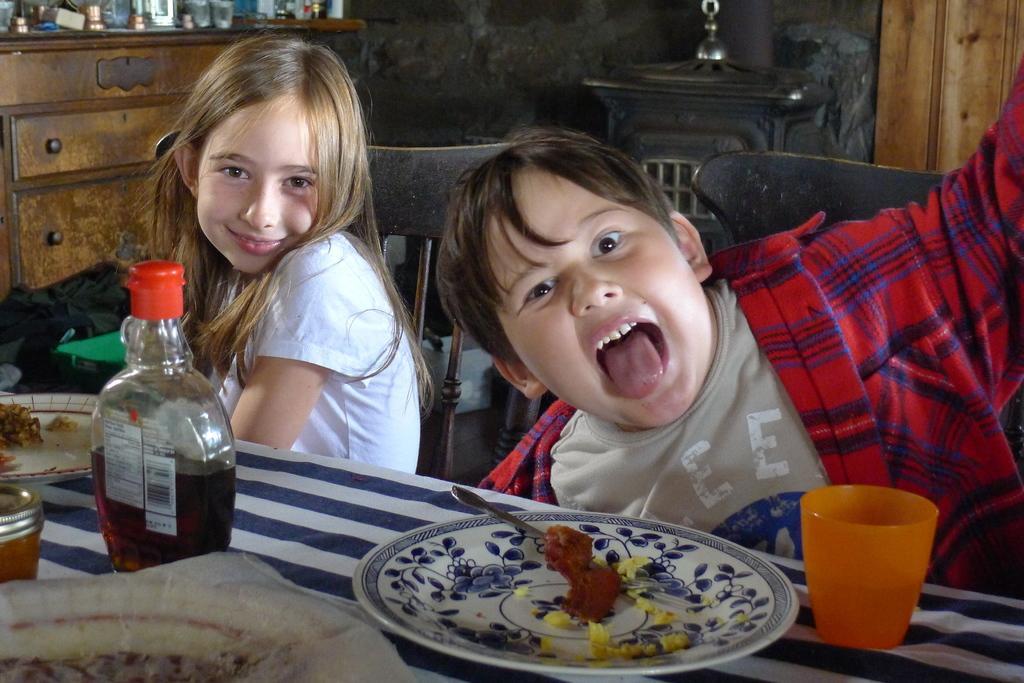In one or two sentences, can you explain what this image depicts? As we can see in the image there are two people, cupboards and table. On table there are plates, glass and bottle. 